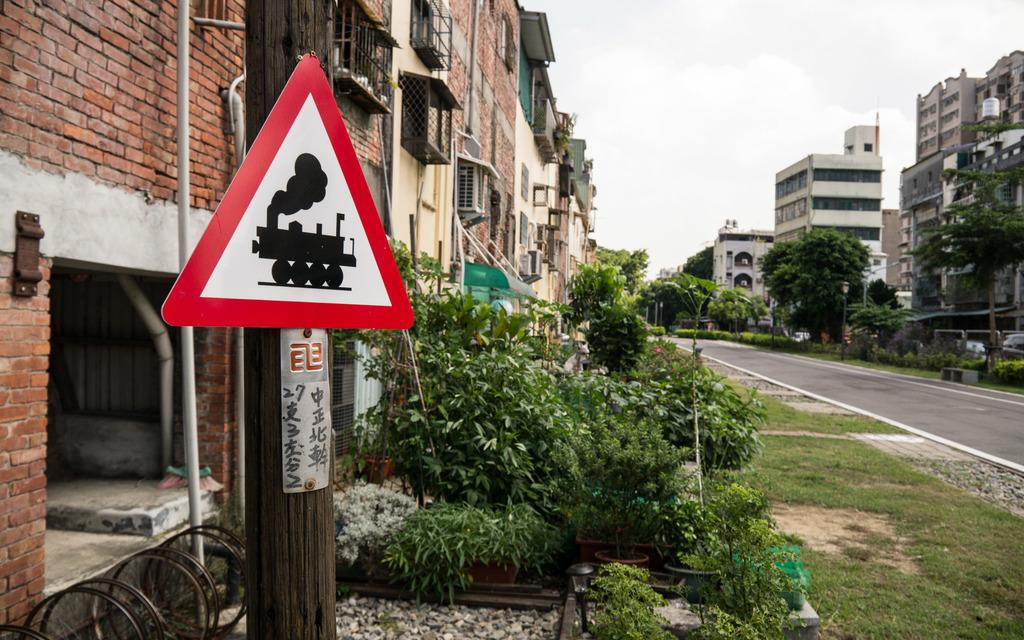Provide a one-sentence caption for the provided image. A steam locomotive ahead warning sign is in the foreground of this image taken on a quiet city street near a large brick building and several green shrubs. 